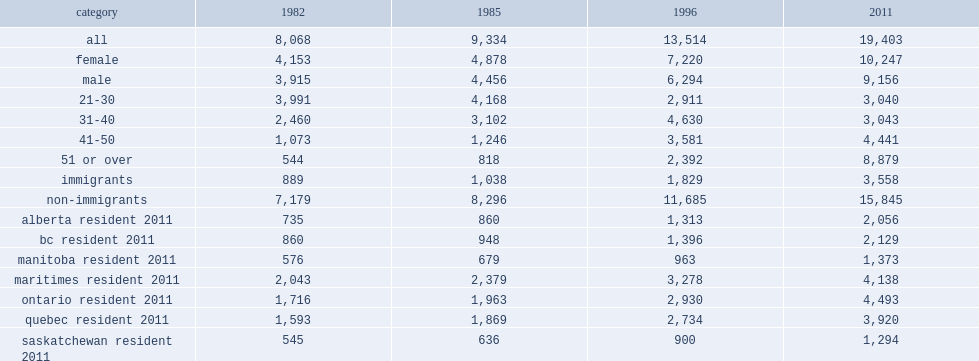Which age group has the highest linkage rate of all age groups in 2011? 51 or over. 